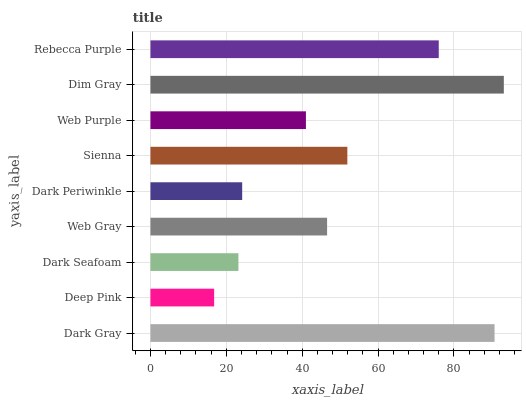Is Deep Pink the minimum?
Answer yes or no. Yes. Is Dim Gray the maximum?
Answer yes or no. Yes. Is Dark Seafoam the minimum?
Answer yes or no. No. Is Dark Seafoam the maximum?
Answer yes or no. No. Is Dark Seafoam greater than Deep Pink?
Answer yes or no. Yes. Is Deep Pink less than Dark Seafoam?
Answer yes or no. Yes. Is Deep Pink greater than Dark Seafoam?
Answer yes or no. No. Is Dark Seafoam less than Deep Pink?
Answer yes or no. No. Is Web Gray the high median?
Answer yes or no. Yes. Is Web Gray the low median?
Answer yes or no. Yes. Is Deep Pink the high median?
Answer yes or no. No. Is Sienna the low median?
Answer yes or no. No. 